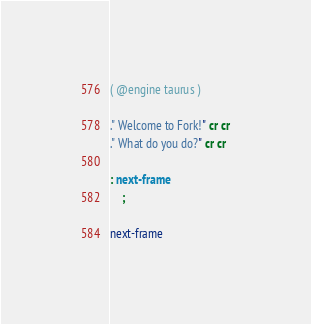Convert code to text. <code><loc_0><loc_0><loc_500><loc_500><_Forth_>( @engine taurus )

." Welcome to Fork!" cr cr
." What do you do?" cr cr

: next-frame
    ;

next-frame
</code> 